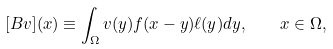Convert formula to latex. <formula><loc_0><loc_0><loc_500><loc_500>[ B v ] ( x ) \equiv \int _ { \Omega } v ( y ) f ( x - y ) \ell ( y ) d y , \quad x \in \Omega ,</formula> 